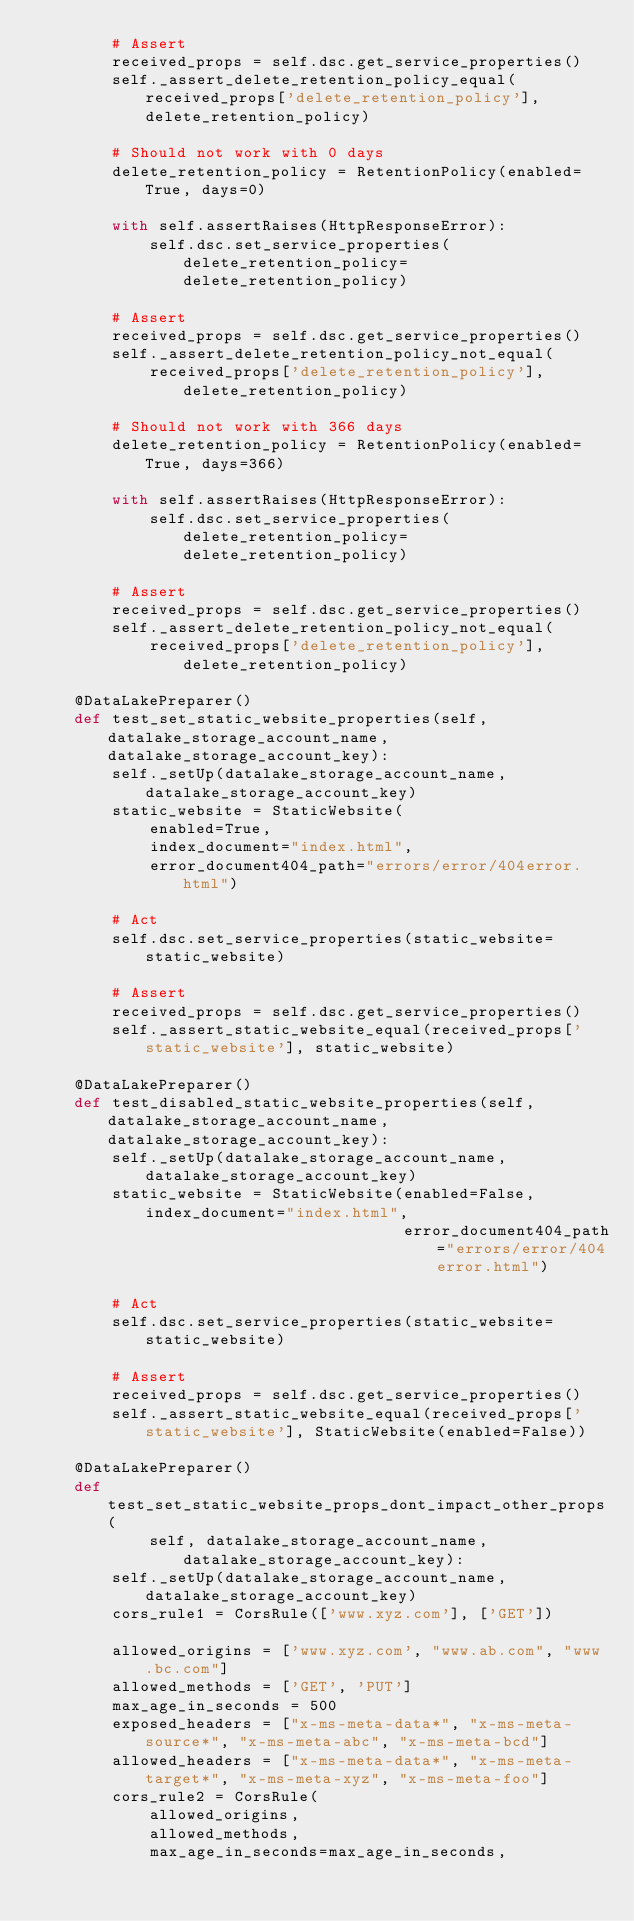<code> <loc_0><loc_0><loc_500><loc_500><_Python_>        # Assert
        received_props = self.dsc.get_service_properties()
        self._assert_delete_retention_policy_equal(received_props['delete_retention_policy'], delete_retention_policy)

        # Should not work with 0 days
        delete_retention_policy = RetentionPolicy(enabled=True, days=0)

        with self.assertRaises(HttpResponseError):
            self.dsc.set_service_properties(delete_retention_policy=delete_retention_policy)

        # Assert
        received_props = self.dsc.get_service_properties()
        self._assert_delete_retention_policy_not_equal(
            received_props['delete_retention_policy'], delete_retention_policy)

        # Should not work with 366 days
        delete_retention_policy = RetentionPolicy(enabled=True, days=366)

        with self.assertRaises(HttpResponseError):
            self.dsc.set_service_properties(delete_retention_policy=delete_retention_policy)

        # Assert
        received_props = self.dsc.get_service_properties()
        self._assert_delete_retention_policy_not_equal(
            received_props['delete_retention_policy'], delete_retention_policy)

    @DataLakePreparer()
    def test_set_static_website_properties(self, datalake_storage_account_name, datalake_storage_account_key):
        self._setUp(datalake_storage_account_name, datalake_storage_account_key)
        static_website = StaticWebsite(
            enabled=True,
            index_document="index.html",
            error_document404_path="errors/error/404error.html")

        # Act
        self.dsc.set_service_properties(static_website=static_website)

        # Assert
        received_props = self.dsc.get_service_properties()
        self._assert_static_website_equal(received_props['static_website'], static_website)

    @DataLakePreparer()
    def test_disabled_static_website_properties(self, datalake_storage_account_name, datalake_storage_account_key):
        self._setUp(datalake_storage_account_name, datalake_storage_account_key)
        static_website = StaticWebsite(enabled=False, index_document="index.html",
                                       error_document404_path="errors/error/404error.html")

        # Act
        self.dsc.set_service_properties(static_website=static_website)

        # Assert
        received_props = self.dsc.get_service_properties()
        self._assert_static_website_equal(received_props['static_website'], StaticWebsite(enabled=False))

    @DataLakePreparer()
    def test_set_static_website_props_dont_impact_other_props(
            self, datalake_storage_account_name, datalake_storage_account_key):
        self._setUp(datalake_storage_account_name, datalake_storage_account_key)
        cors_rule1 = CorsRule(['www.xyz.com'], ['GET'])

        allowed_origins = ['www.xyz.com', "www.ab.com", "www.bc.com"]
        allowed_methods = ['GET', 'PUT']
        max_age_in_seconds = 500
        exposed_headers = ["x-ms-meta-data*", "x-ms-meta-source*", "x-ms-meta-abc", "x-ms-meta-bcd"]
        allowed_headers = ["x-ms-meta-data*", "x-ms-meta-target*", "x-ms-meta-xyz", "x-ms-meta-foo"]
        cors_rule2 = CorsRule(
            allowed_origins,
            allowed_methods,
            max_age_in_seconds=max_age_in_seconds,</code> 